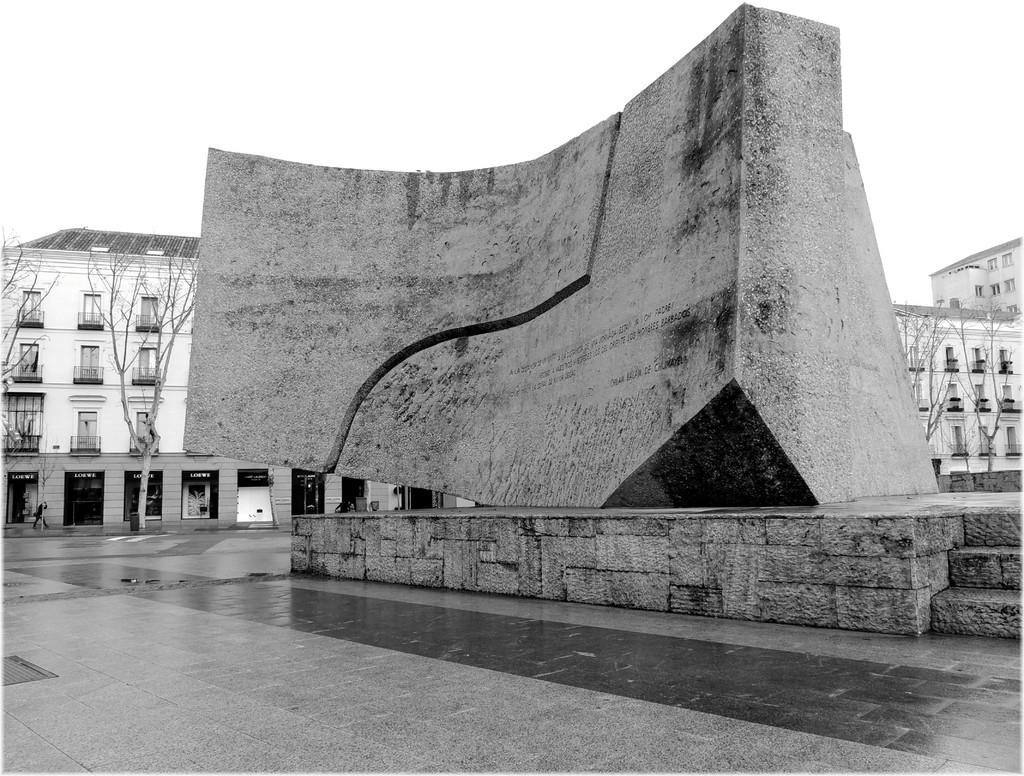What is the main subject in the middle of the image? There is a stone sculpture in the middle of the image. What can be seen in the background of the image? There is a building and trees in the background of the image. Can you describe the building in the background? The building has glass windows. What sense is being stimulated by the stone sculpture in the image? The image does not provide information about any senses being stimulated by the stone sculpture. 